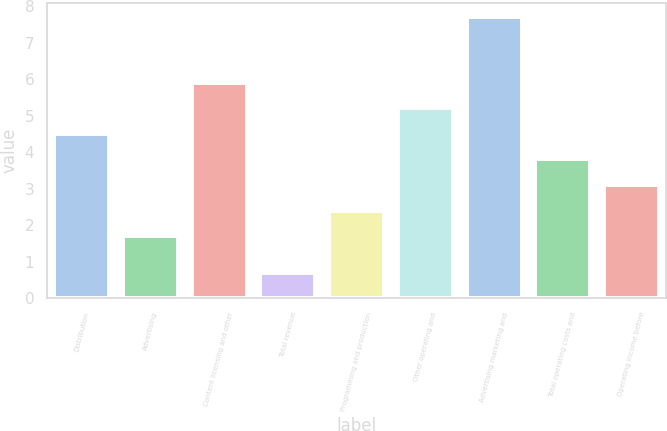Convert chart. <chart><loc_0><loc_0><loc_500><loc_500><bar_chart><fcel>Distribution<fcel>Advertising<fcel>Content licensing and other<fcel>Total revenue<fcel>Programming and production<fcel>Other operating and<fcel>Advertising marketing and<fcel>Total operating costs and<fcel>Operating income before<nl><fcel>4.5<fcel>1.7<fcel>5.9<fcel>0.7<fcel>2.4<fcel>5.2<fcel>7.7<fcel>3.8<fcel>3.1<nl></chart> 